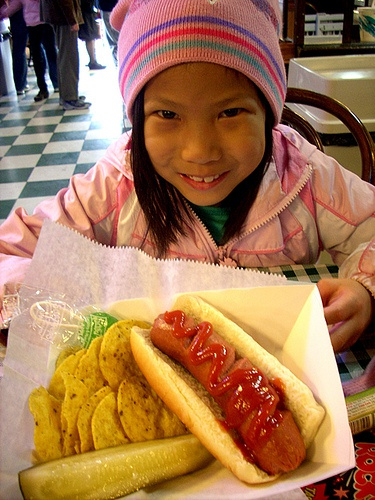Describe the objects in this image and their specific colors. I can see dining table in black, tan, orange, and olive tones, people in black, brown, and maroon tones, hot dog in black, maroon, gold, brown, and khaki tones, chair in black, olive, maroon, and darkgray tones, and people in black and gray tones in this image. 